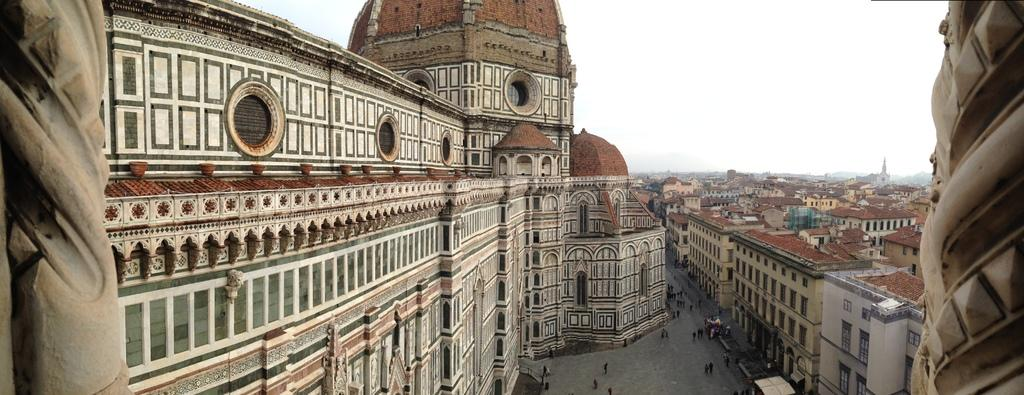What type of structures can be seen in the image? There are buildings in the image. What else is present in the image besides the buildings? There is a road and people walking in the image. What is visible at the top of the image? The sky is visible at the top of the image. What type of alarm is going off in the image? There is no alarm present in the image. Can you tell me which minister is walking in the image? There is no minister present in the image; it only shows people walking. 